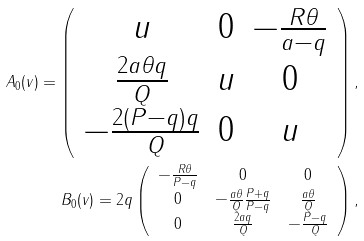<formula> <loc_0><loc_0><loc_500><loc_500>{ A _ { 0 } ( v ) } = \left ( \begin{array} { c c c } u & 0 & - \frac { R \theta } { a - q } \\ \frac { 2 a \theta q } { Q } & u & 0 \\ - \frac { 2 ( P - q ) q } { Q } & 0 & u \end{array} \right ) , \\ { B _ { 0 } ( v ) } = 2 q \left ( \begin{array} { c c c } - \frac { R \theta } { P - q } & 0 & 0 \\ 0 & - \frac { a \theta } { Q } \frac { P + q } { P - q } & \frac { a \theta } { Q } \\ 0 & \frac { 2 a q } { Q } & - \frac { P - q } { Q } \end{array} \right ) ,</formula> 